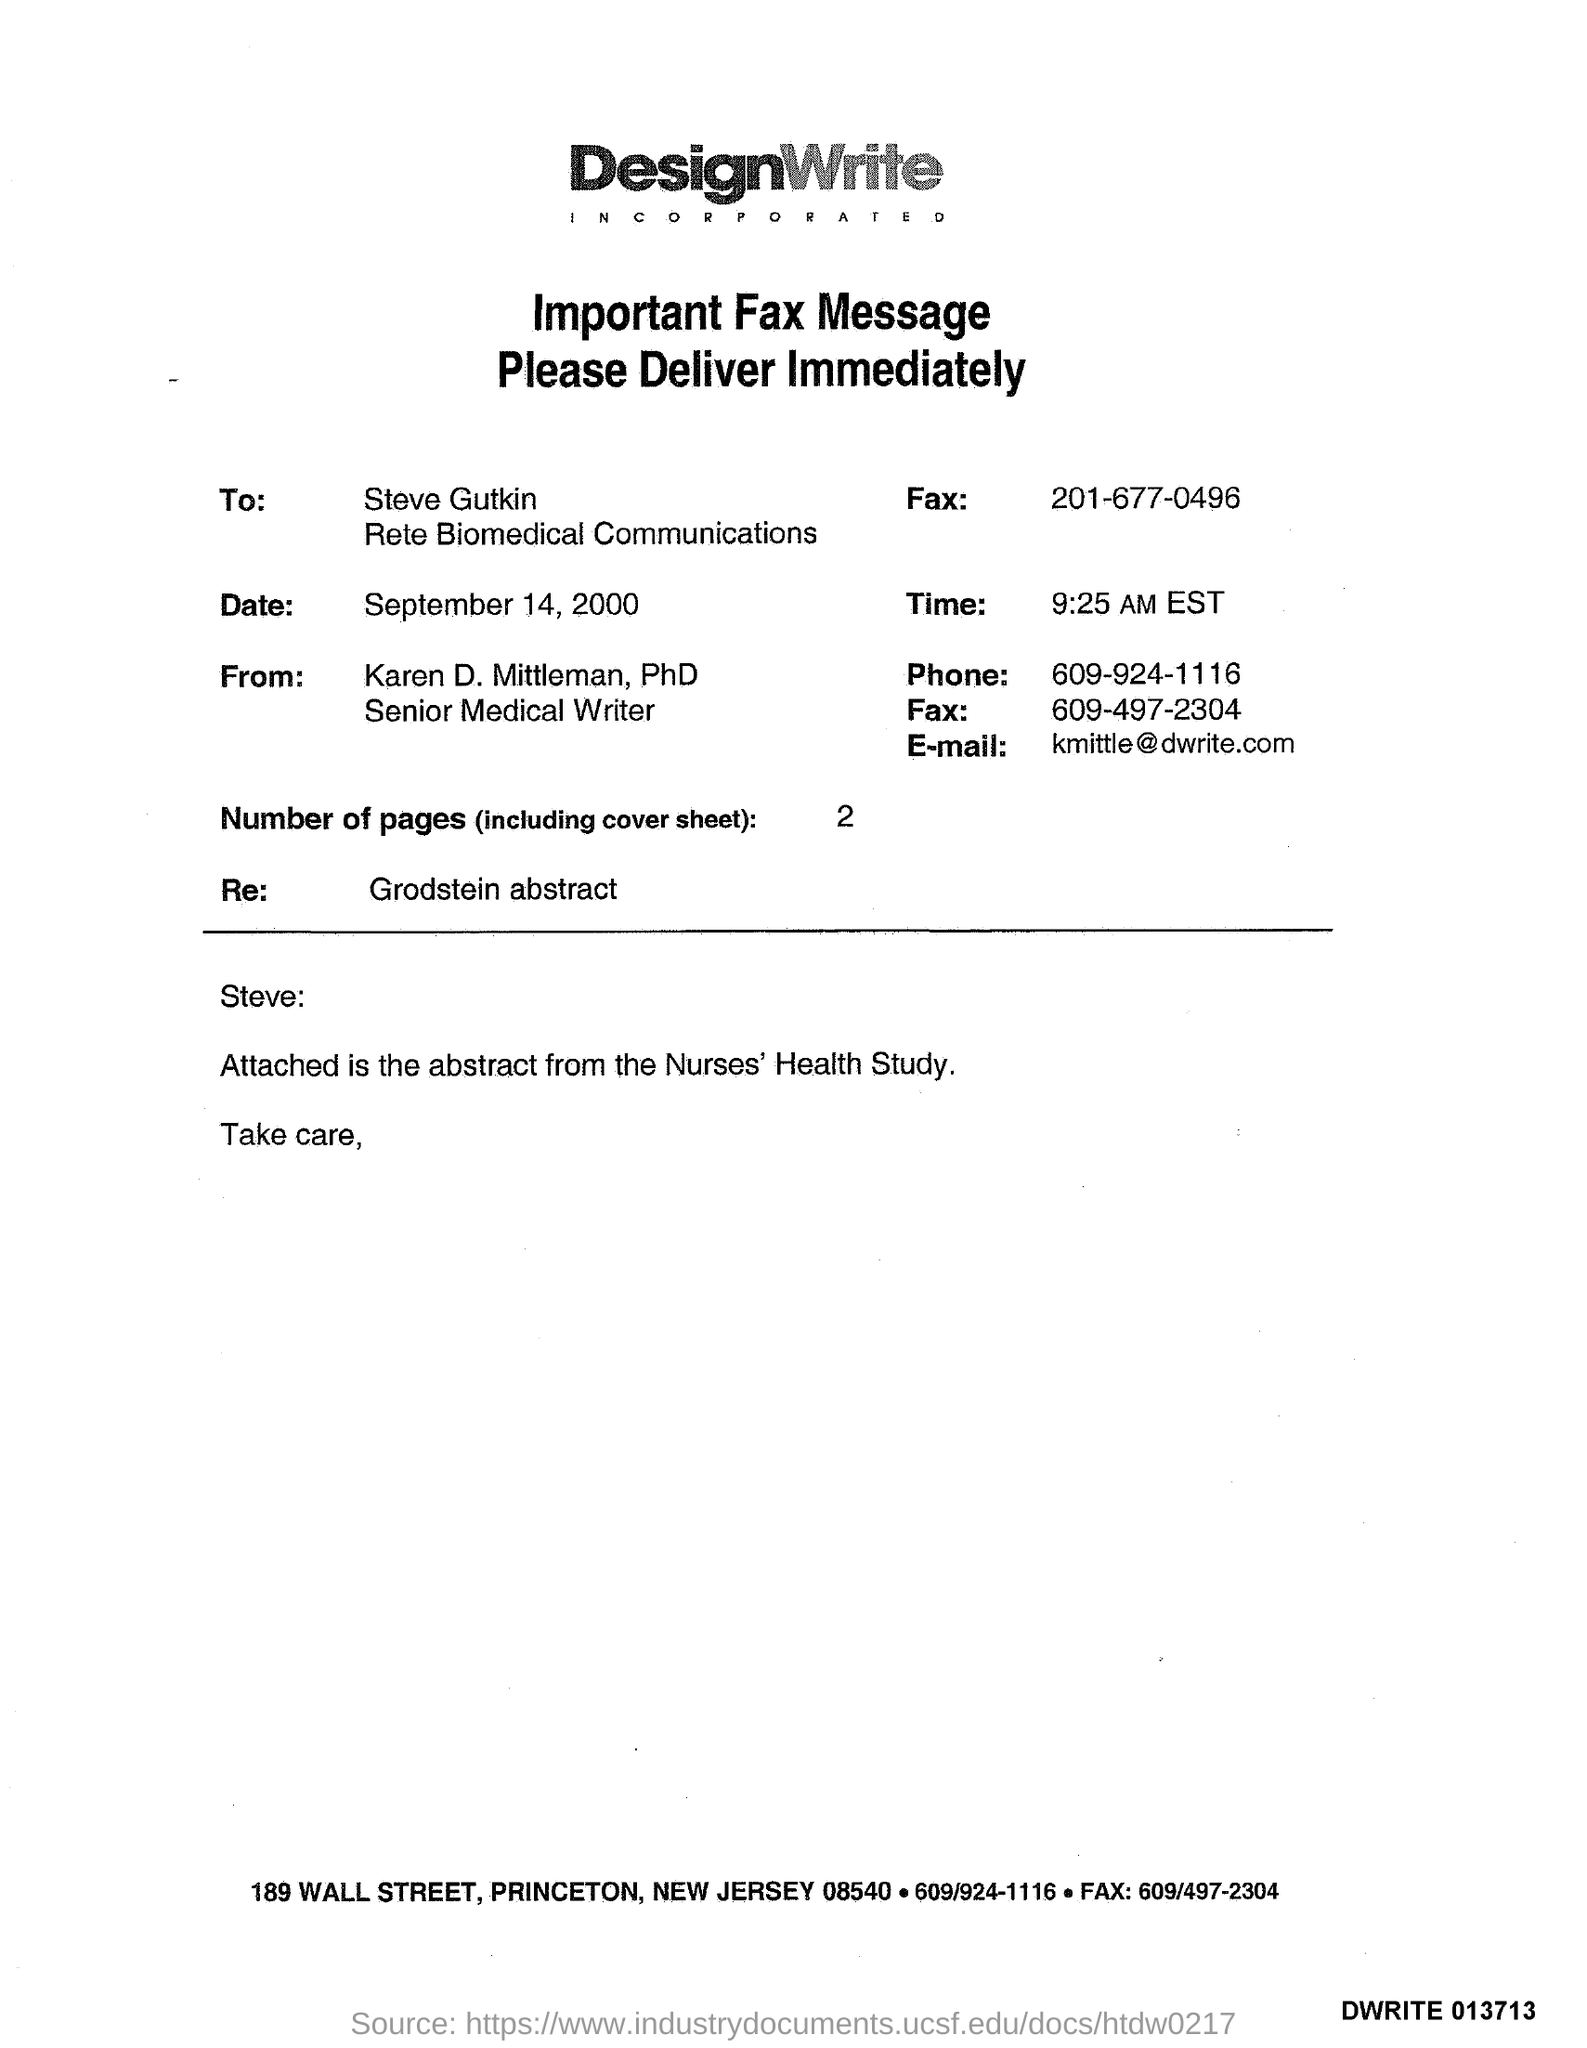To Whom is this Fax addressed to?
Give a very brief answer. Steve Gutkin Rete Biomedical Communications. What is the date on the Fax?
Offer a very short reply. September 14, 2000. What is the Time?
Ensure brevity in your answer.  9:25 AM EST. Who is the Fax from?
Your response must be concise. Karen D. Mittleman, PhD. What is the Phone?
Offer a terse response. 609-924-1116. What is the E-mail?
Ensure brevity in your answer.  Kmittle@dwrite.com. What are the Number of pages (including cover sheet)?
Provide a succinct answer. 2. What is the re: ?
Provide a short and direct response. Grodstein abstract. 